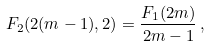Convert formula to latex. <formula><loc_0><loc_0><loc_500><loc_500>F _ { 2 } ( 2 ( m - 1 ) , 2 ) = \frac { F _ { 1 } ( 2 m ) } { 2 m - 1 } \, ,</formula> 